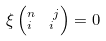<formula> <loc_0><loc_0><loc_500><loc_500>\xi \left ( _ { i \ \ i } ^ { n \ \ j } \right ) = 0</formula> 